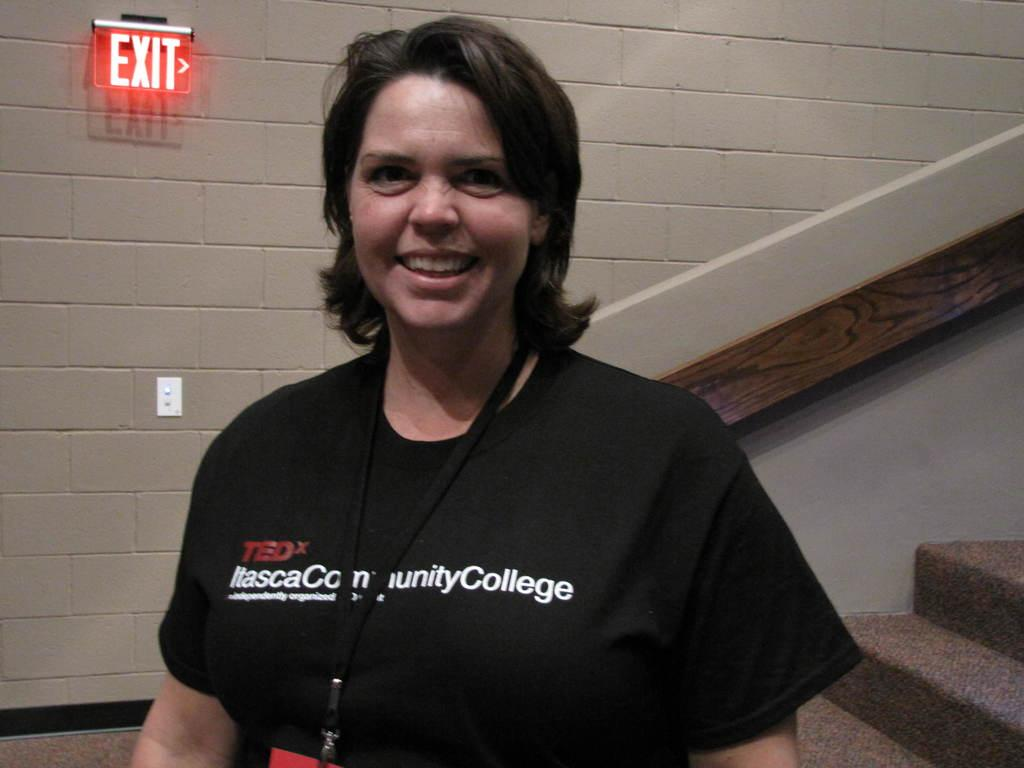Who is the main subject in the image? There is a lady in the image. What is the lady wearing that is visible in the image? The lady is wearing a tag. What can be seen in the background of the image? There is a wall with an exit board in the background. What architectural feature is present on the right side of the image? There are steps with a side wall on the right side. What type of record is being played in the image? There is no record player or record visible in the image. 